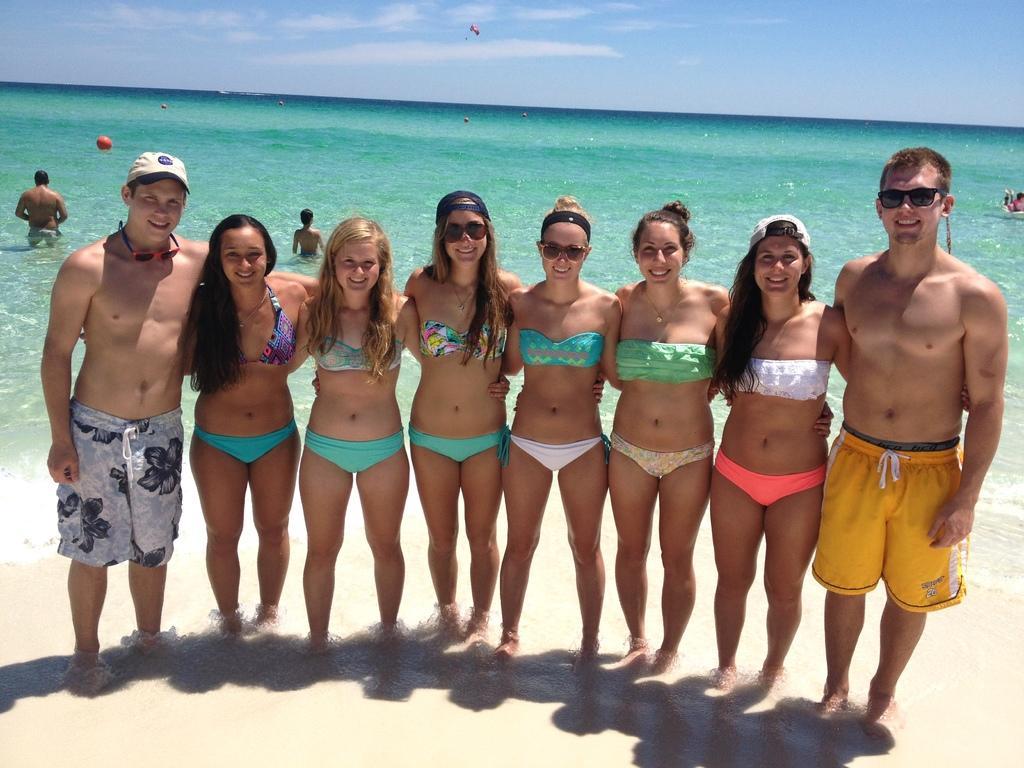Describe this image in one or two sentences. In this image we can see many persons standing on the sand. In the background we can see water, person's, parachute, sky and clouds. 